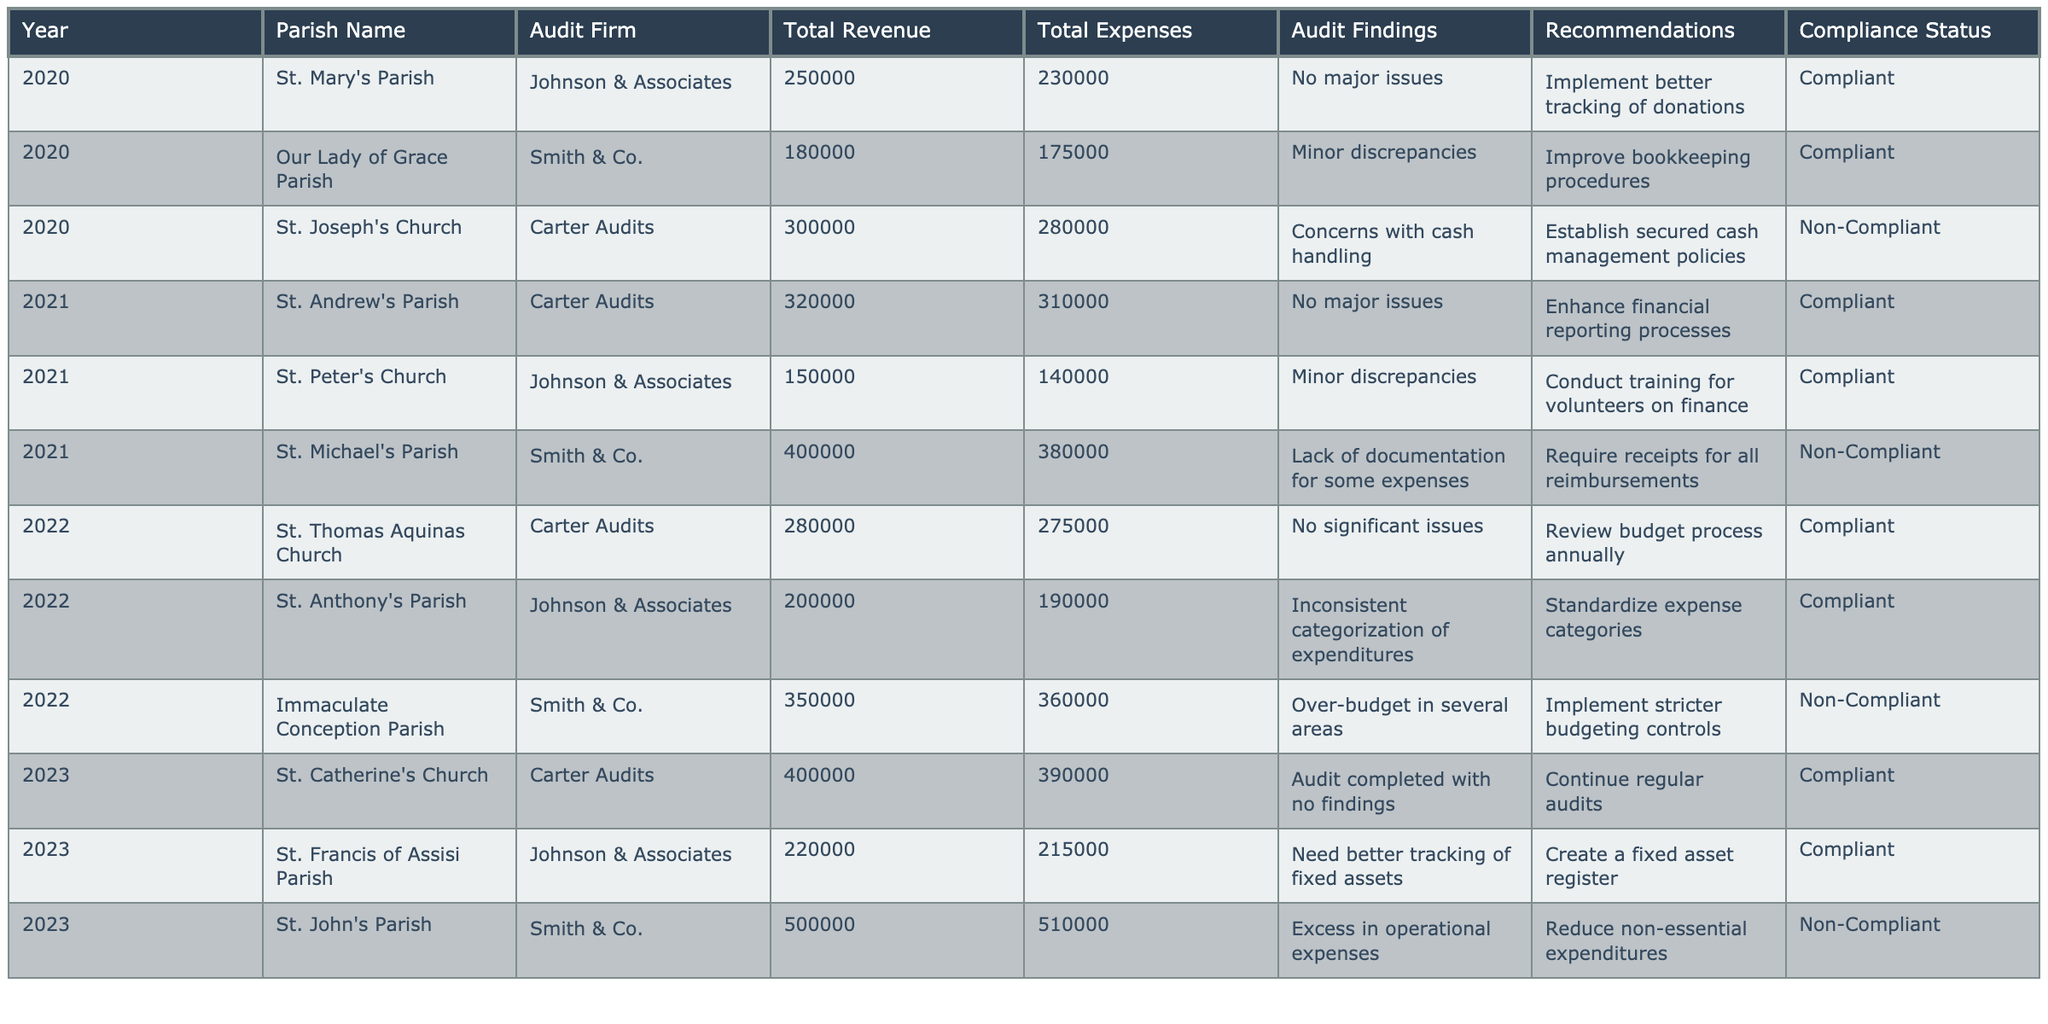What is the total revenue for St. Joseph's Church in 2020? The table lists the total revenue for St. Joseph's Church in 2020 as 300,000.
Answer: 300,000 How many parishes had "No major issues" in their audit findings from 2020 to 2023? There are three instances of "No major issues" in the audit findings: for St. Mary's Parish (2020), St. Andrew's Parish (2021), and St. Catherine's Church (2023).
Answer: 3 Which parish had the highest total expenses in 2023? The table shows that St. John's Parish had the highest total expenses in 2023, totaling 510,000.
Answer: St. John's Parish What were the total expenses for parishes that received "Non-Compliant" status across all years? Adding the total expenses for the non-compliant parishes: St. Joseph's Church (280,000) + St. Michael's Parish (380,000) + Immaculate Conception Parish (360,000) + St. John's Parish (510,000) gives a total of 1,530,000.
Answer: 1,530,000 What recommendations were provided for Our Lady of Grace Parish? The table shows that the recommendation for Our Lady of Grace Parish was to "Improve bookkeeping procedures."
Answer: Improve bookkeeping procedures In which year did St. Anthony's Parish receive a "Compliant" status? According to the table, St. Anthony's Parish had a compliant status in 2022.
Answer: 2022 Which audit firm was involved with the parish that had the largest total revenue in 2023? In 2023, St. John's Parish had the largest total revenue of 500,000, and it was audited by Smith & Co.
Answer: Smith & Co Of the parishes audited in 2021, how many were deemed "Non-Compliant"? The table lists St. Michael's Parish as the only non-compliant parish in 2021.
Answer: 1 What is the difference between total revenue and total expenses for St. Thomas Aquinas Church in 2022? For St. Thomas Aquinas Church in 2022, the total revenue is 280,000 and total expenses are 275,000. The difference is 280,000 - 275,000 = 5,000.
Answer: 5,000 How many parishes received recommendations to improve their financial practices? Based on the table, all parishes with audit findings received recommendations, totaling six that were advised to enhance their financial practices.
Answer: 6 